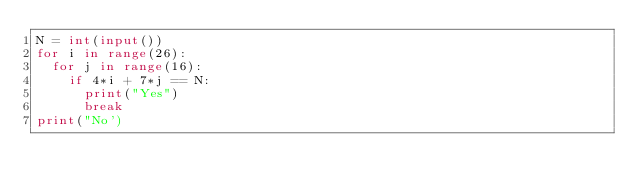<code> <loc_0><loc_0><loc_500><loc_500><_Python_>N = int(input())
for i in range(26):
  for j in range(16):
	if 4*i + 7*j == N:
	  print("Yes")
	  break
print("No')</code> 